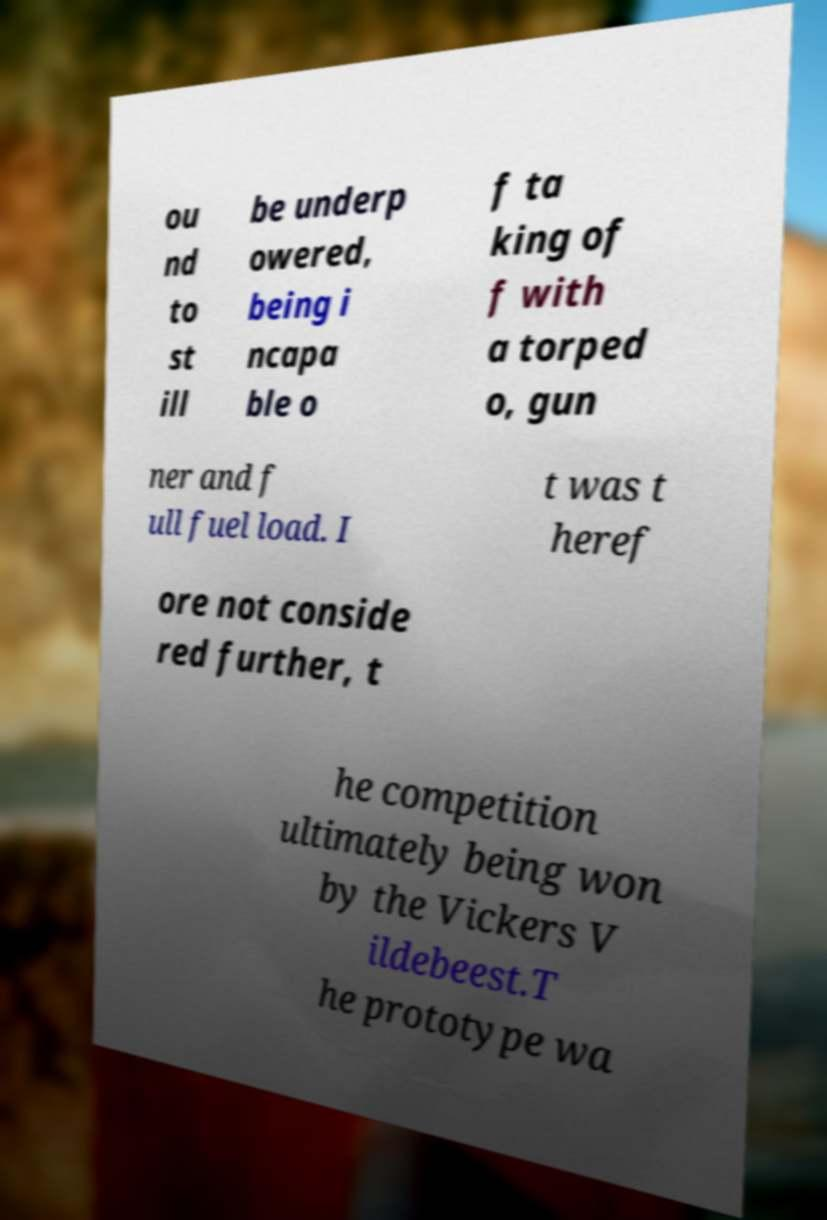Could you extract and type out the text from this image? ou nd to st ill be underp owered, being i ncapa ble o f ta king of f with a torped o, gun ner and f ull fuel load. I t was t heref ore not conside red further, t he competition ultimately being won by the Vickers V ildebeest.T he prototype wa 